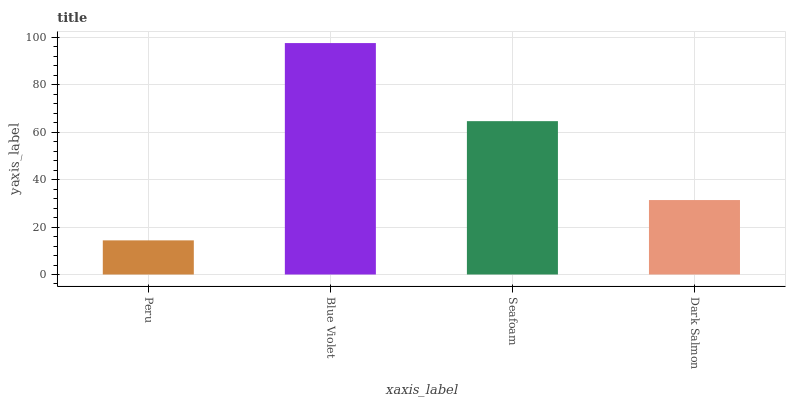Is Peru the minimum?
Answer yes or no. Yes. Is Blue Violet the maximum?
Answer yes or no. Yes. Is Seafoam the minimum?
Answer yes or no. No. Is Seafoam the maximum?
Answer yes or no. No. Is Blue Violet greater than Seafoam?
Answer yes or no. Yes. Is Seafoam less than Blue Violet?
Answer yes or no. Yes. Is Seafoam greater than Blue Violet?
Answer yes or no. No. Is Blue Violet less than Seafoam?
Answer yes or no. No. Is Seafoam the high median?
Answer yes or no. Yes. Is Dark Salmon the low median?
Answer yes or no. Yes. Is Blue Violet the high median?
Answer yes or no. No. Is Blue Violet the low median?
Answer yes or no. No. 